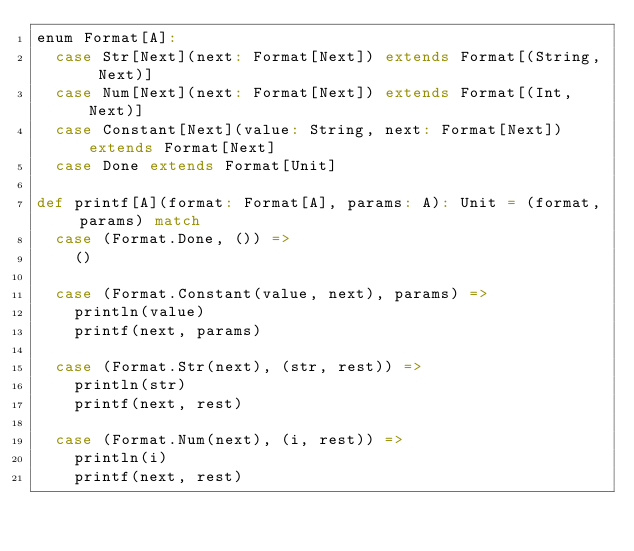<code> <loc_0><loc_0><loc_500><loc_500><_Scala_>enum Format[A]:
  case Str[Next](next: Format[Next]) extends Format[(String, Next)]
  case Num[Next](next: Format[Next]) extends Format[(Int, Next)]
  case Constant[Next](value: String, next: Format[Next]) extends Format[Next]
  case Done extends Format[Unit]

def printf[A](format: Format[A], params: A): Unit = (format, params) match
  case (Format.Done, ()) =>
    ()

  case (Format.Constant(value, next), params) =>
    println(value)
    printf(next, params)

  case (Format.Str(next), (str, rest)) =>
    println(str)
    printf(next, rest)

  case (Format.Num(next), (i, rest)) =>
    println(i)
    printf(next, rest)
</code> 